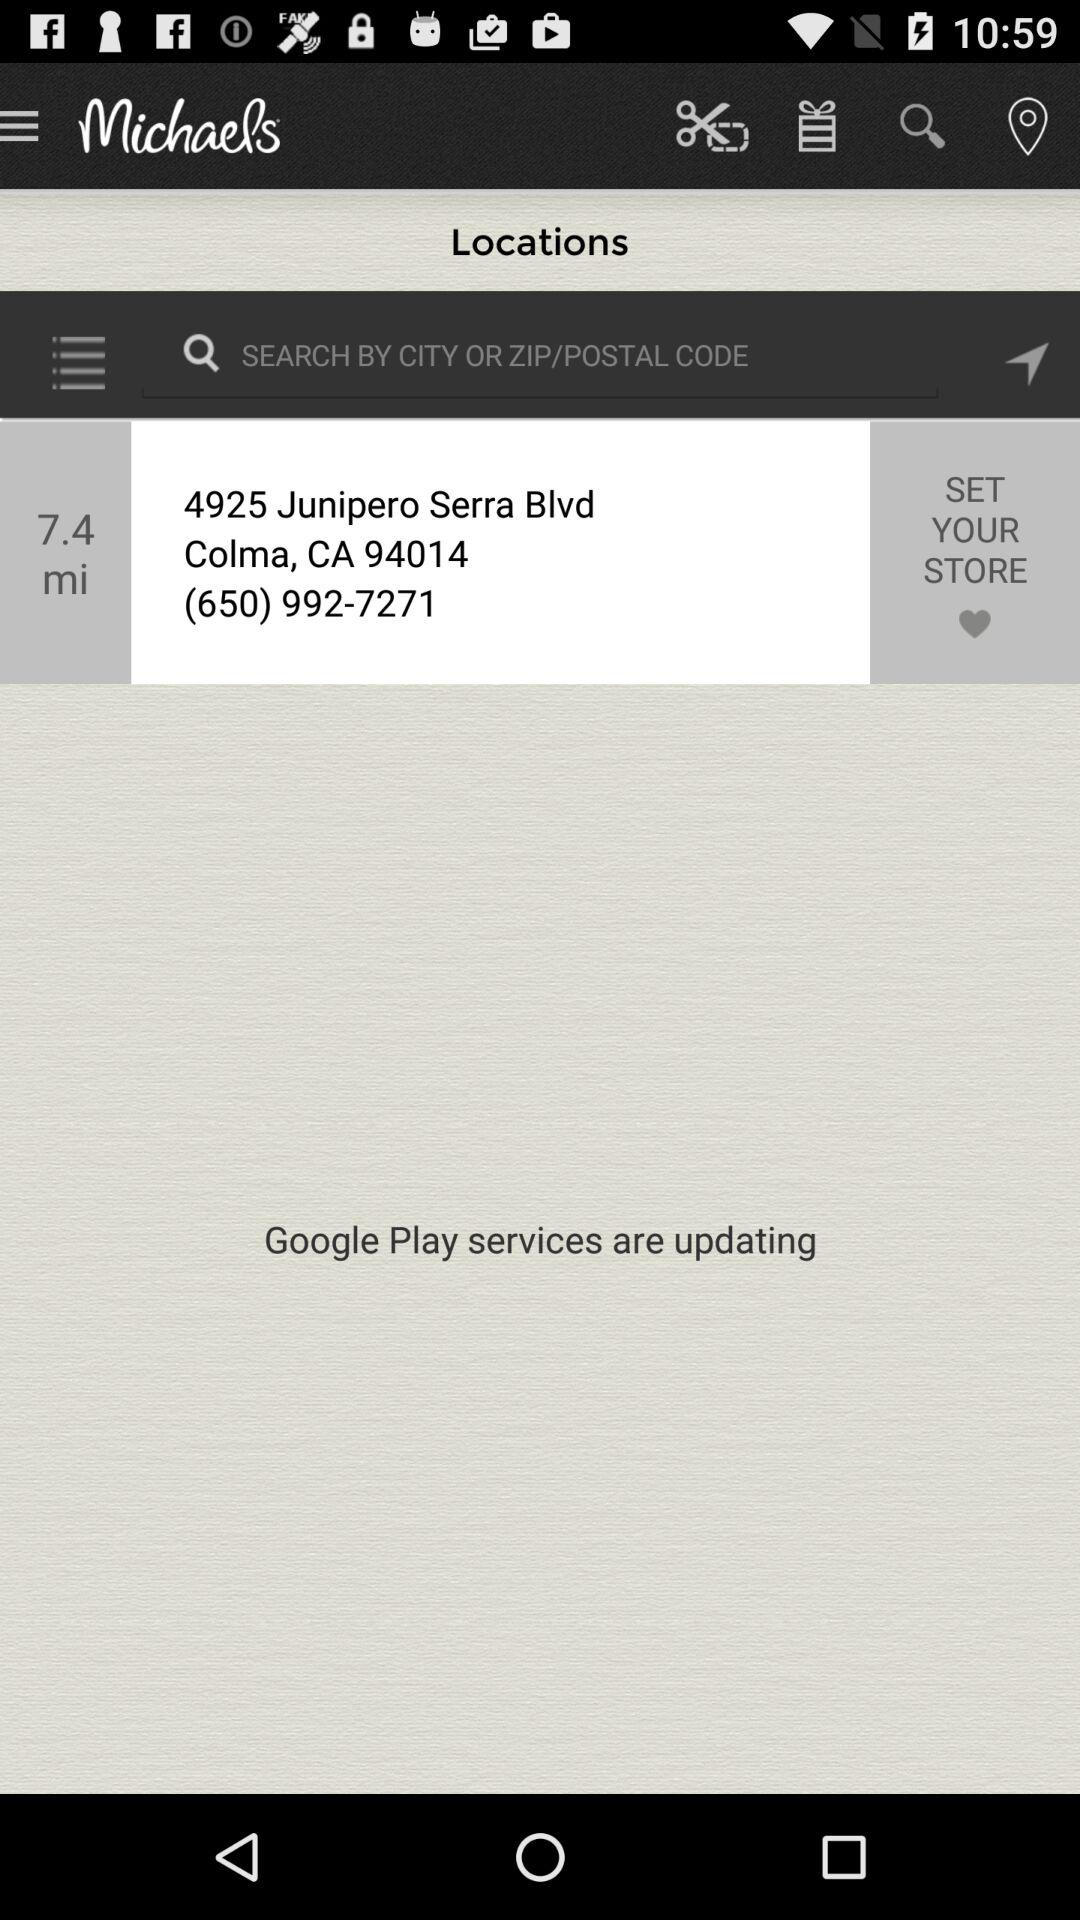What is the given address? The given address is 4925 Junipero Serra Blvd, Colma, CA 94014. 